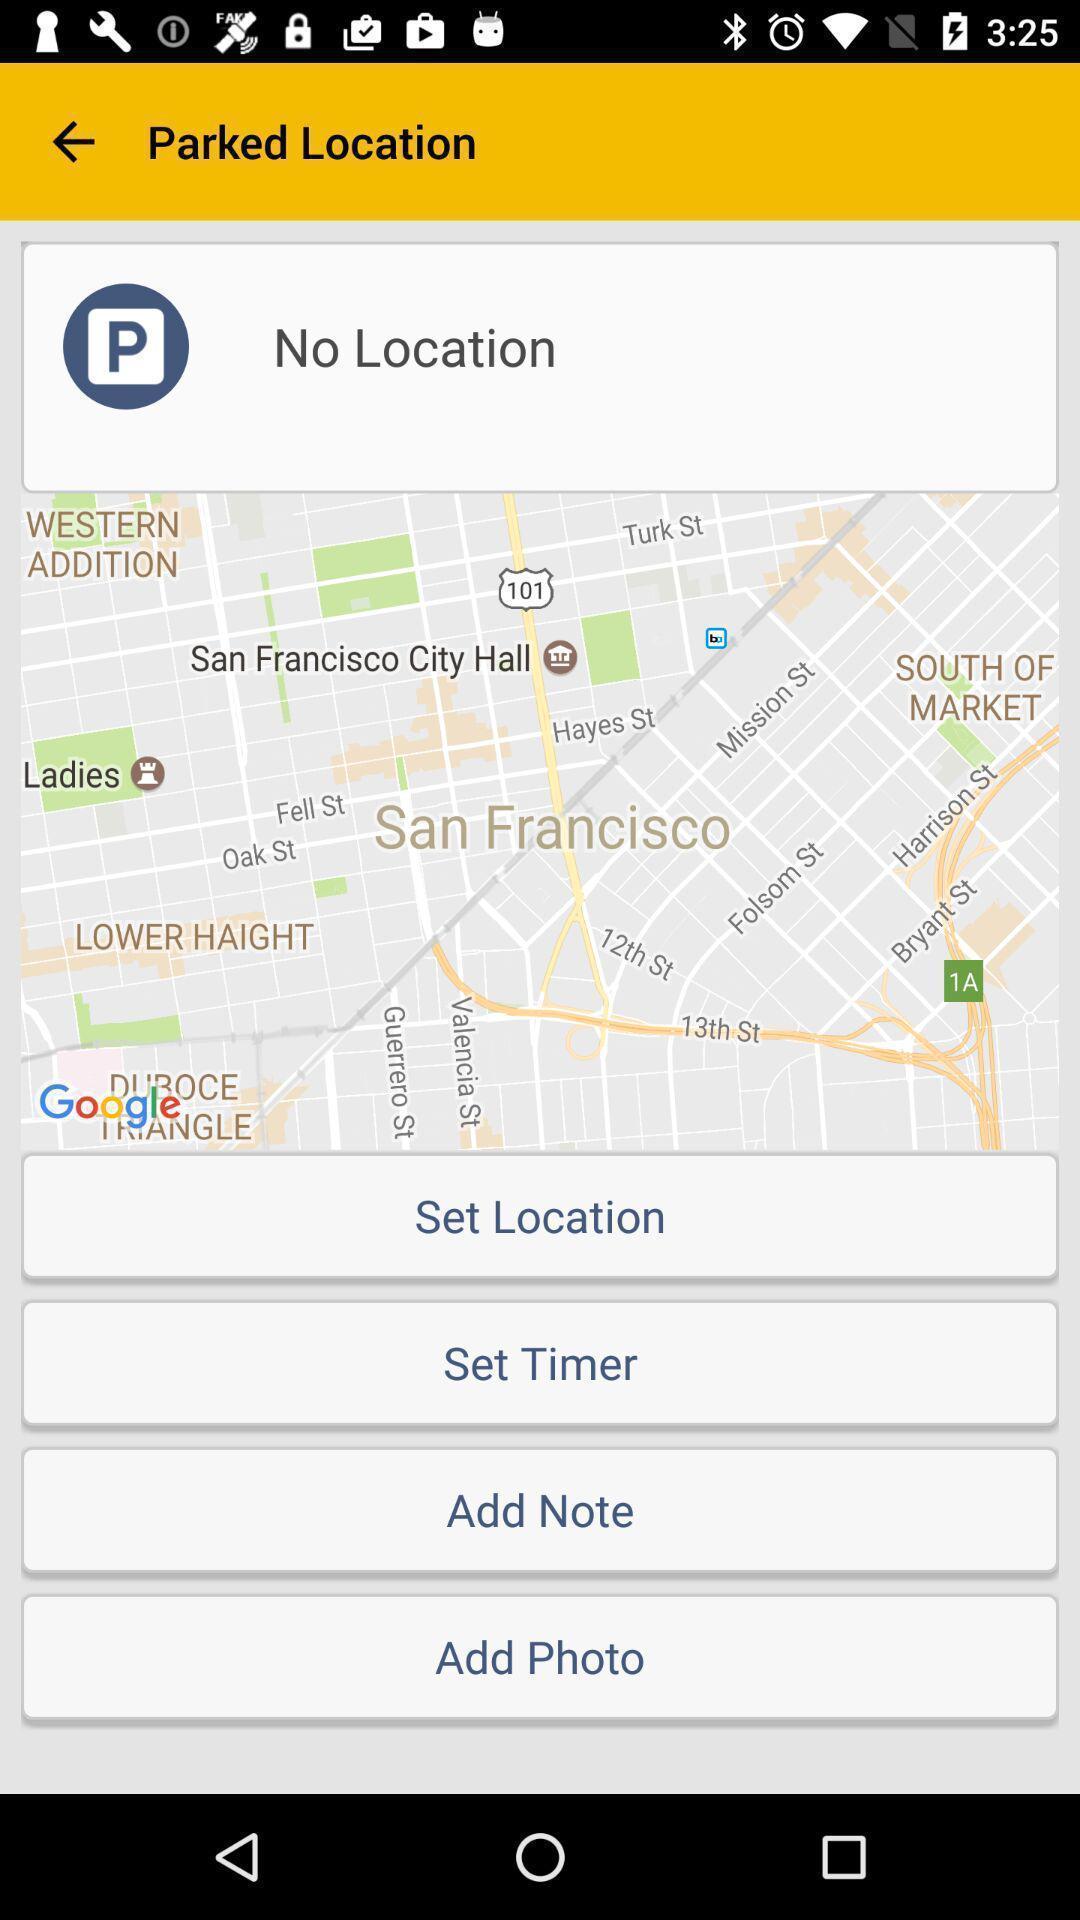Provide a detailed account of this screenshot. Set of options available in a location tracking app. 